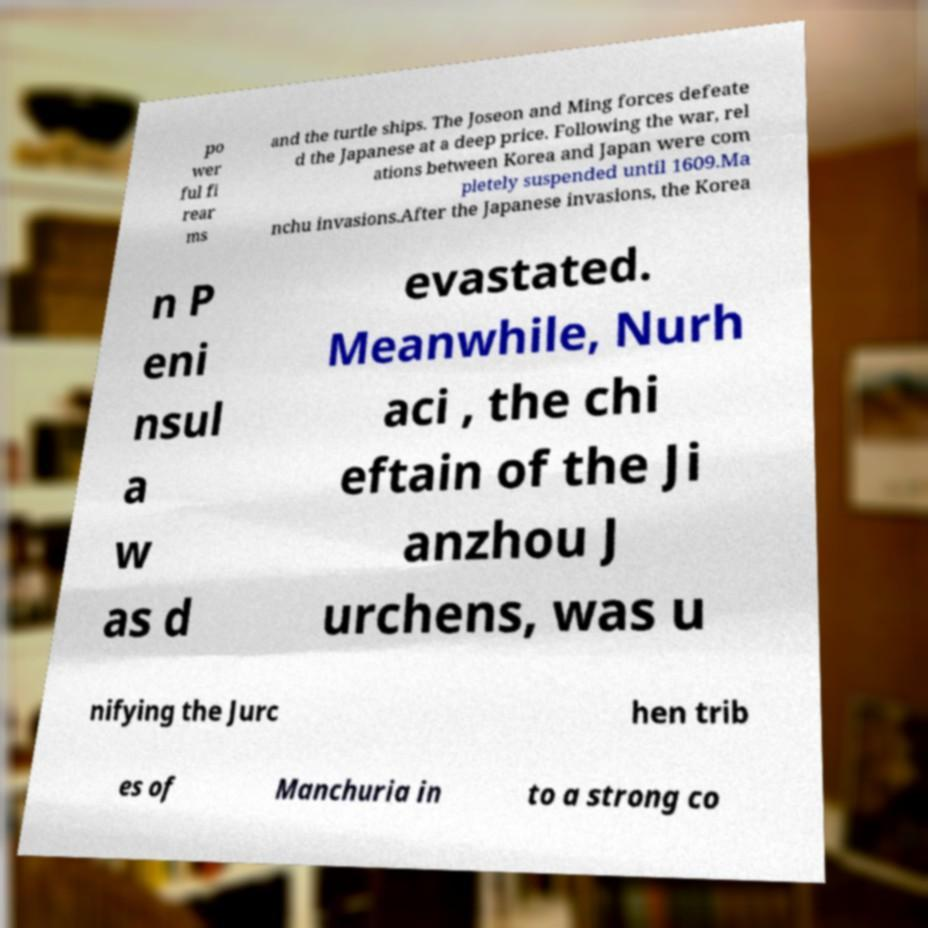There's text embedded in this image that I need extracted. Can you transcribe it verbatim? po wer ful fi rear ms and the turtle ships. The Joseon and Ming forces defeate d the Japanese at a deep price. Following the war, rel ations between Korea and Japan were com pletely suspended until 1609.Ma nchu invasions.After the Japanese invasions, the Korea n P eni nsul a w as d evastated. Meanwhile, Nurh aci , the chi eftain of the Ji anzhou J urchens, was u nifying the Jurc hen trib es of Manchuria in to a strong co 